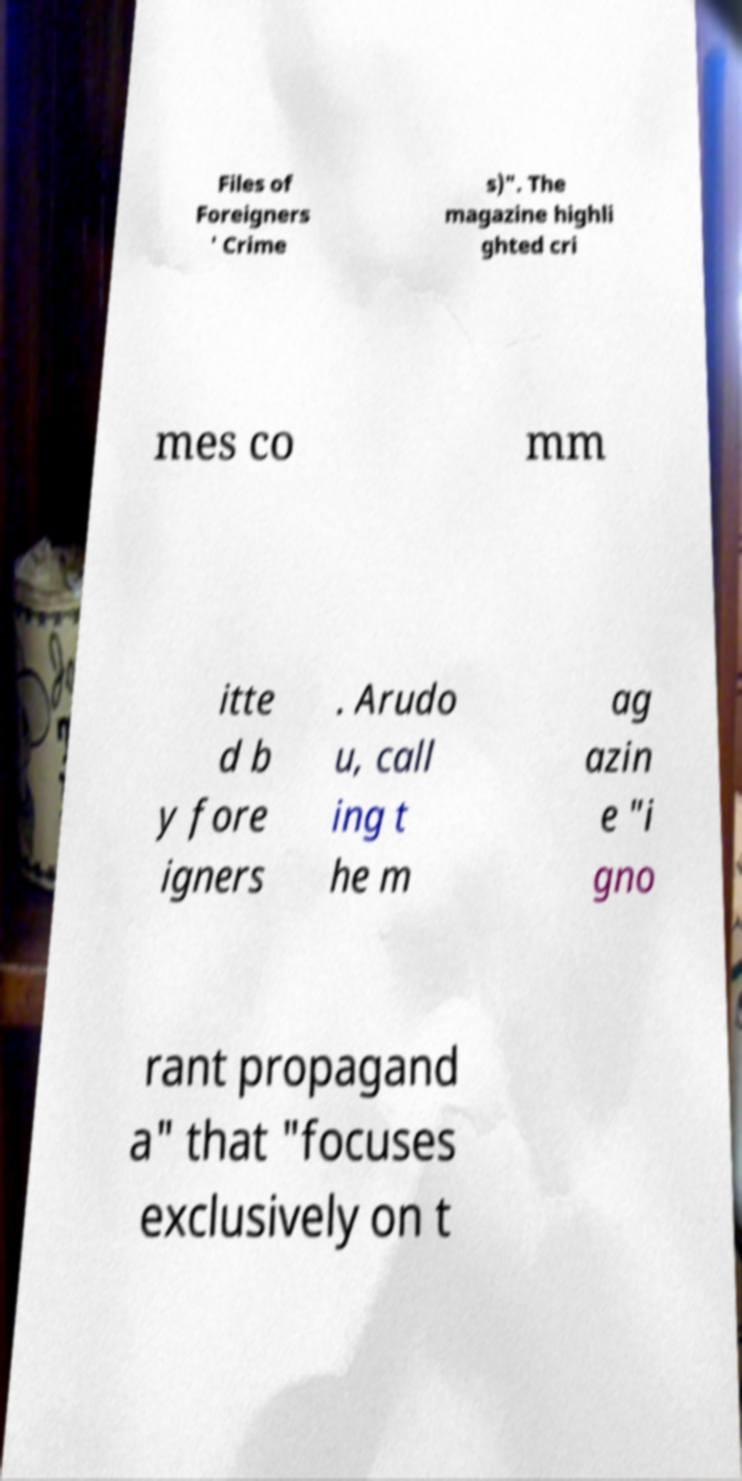Please read and relay the text visible in this image. What does it say? Files of Foreigners ' Crime s)". The magazine highli ghted cri mes co mm itte d b y fore igners . Arudo u, call ing t he m ag azin e "i gno rant propagand a" that "focuses exclusively on t 